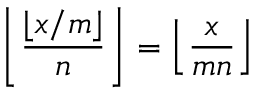Convert formula to latex. <formula><loc_0><loc_0><loc_500><loc_500>\left \lfloor { \frac { \lfloor x / m \rfloor } { n } } \right \rfloor = \left \lfloor { \frac { x } { m n } } \right \rfloor</formula> 